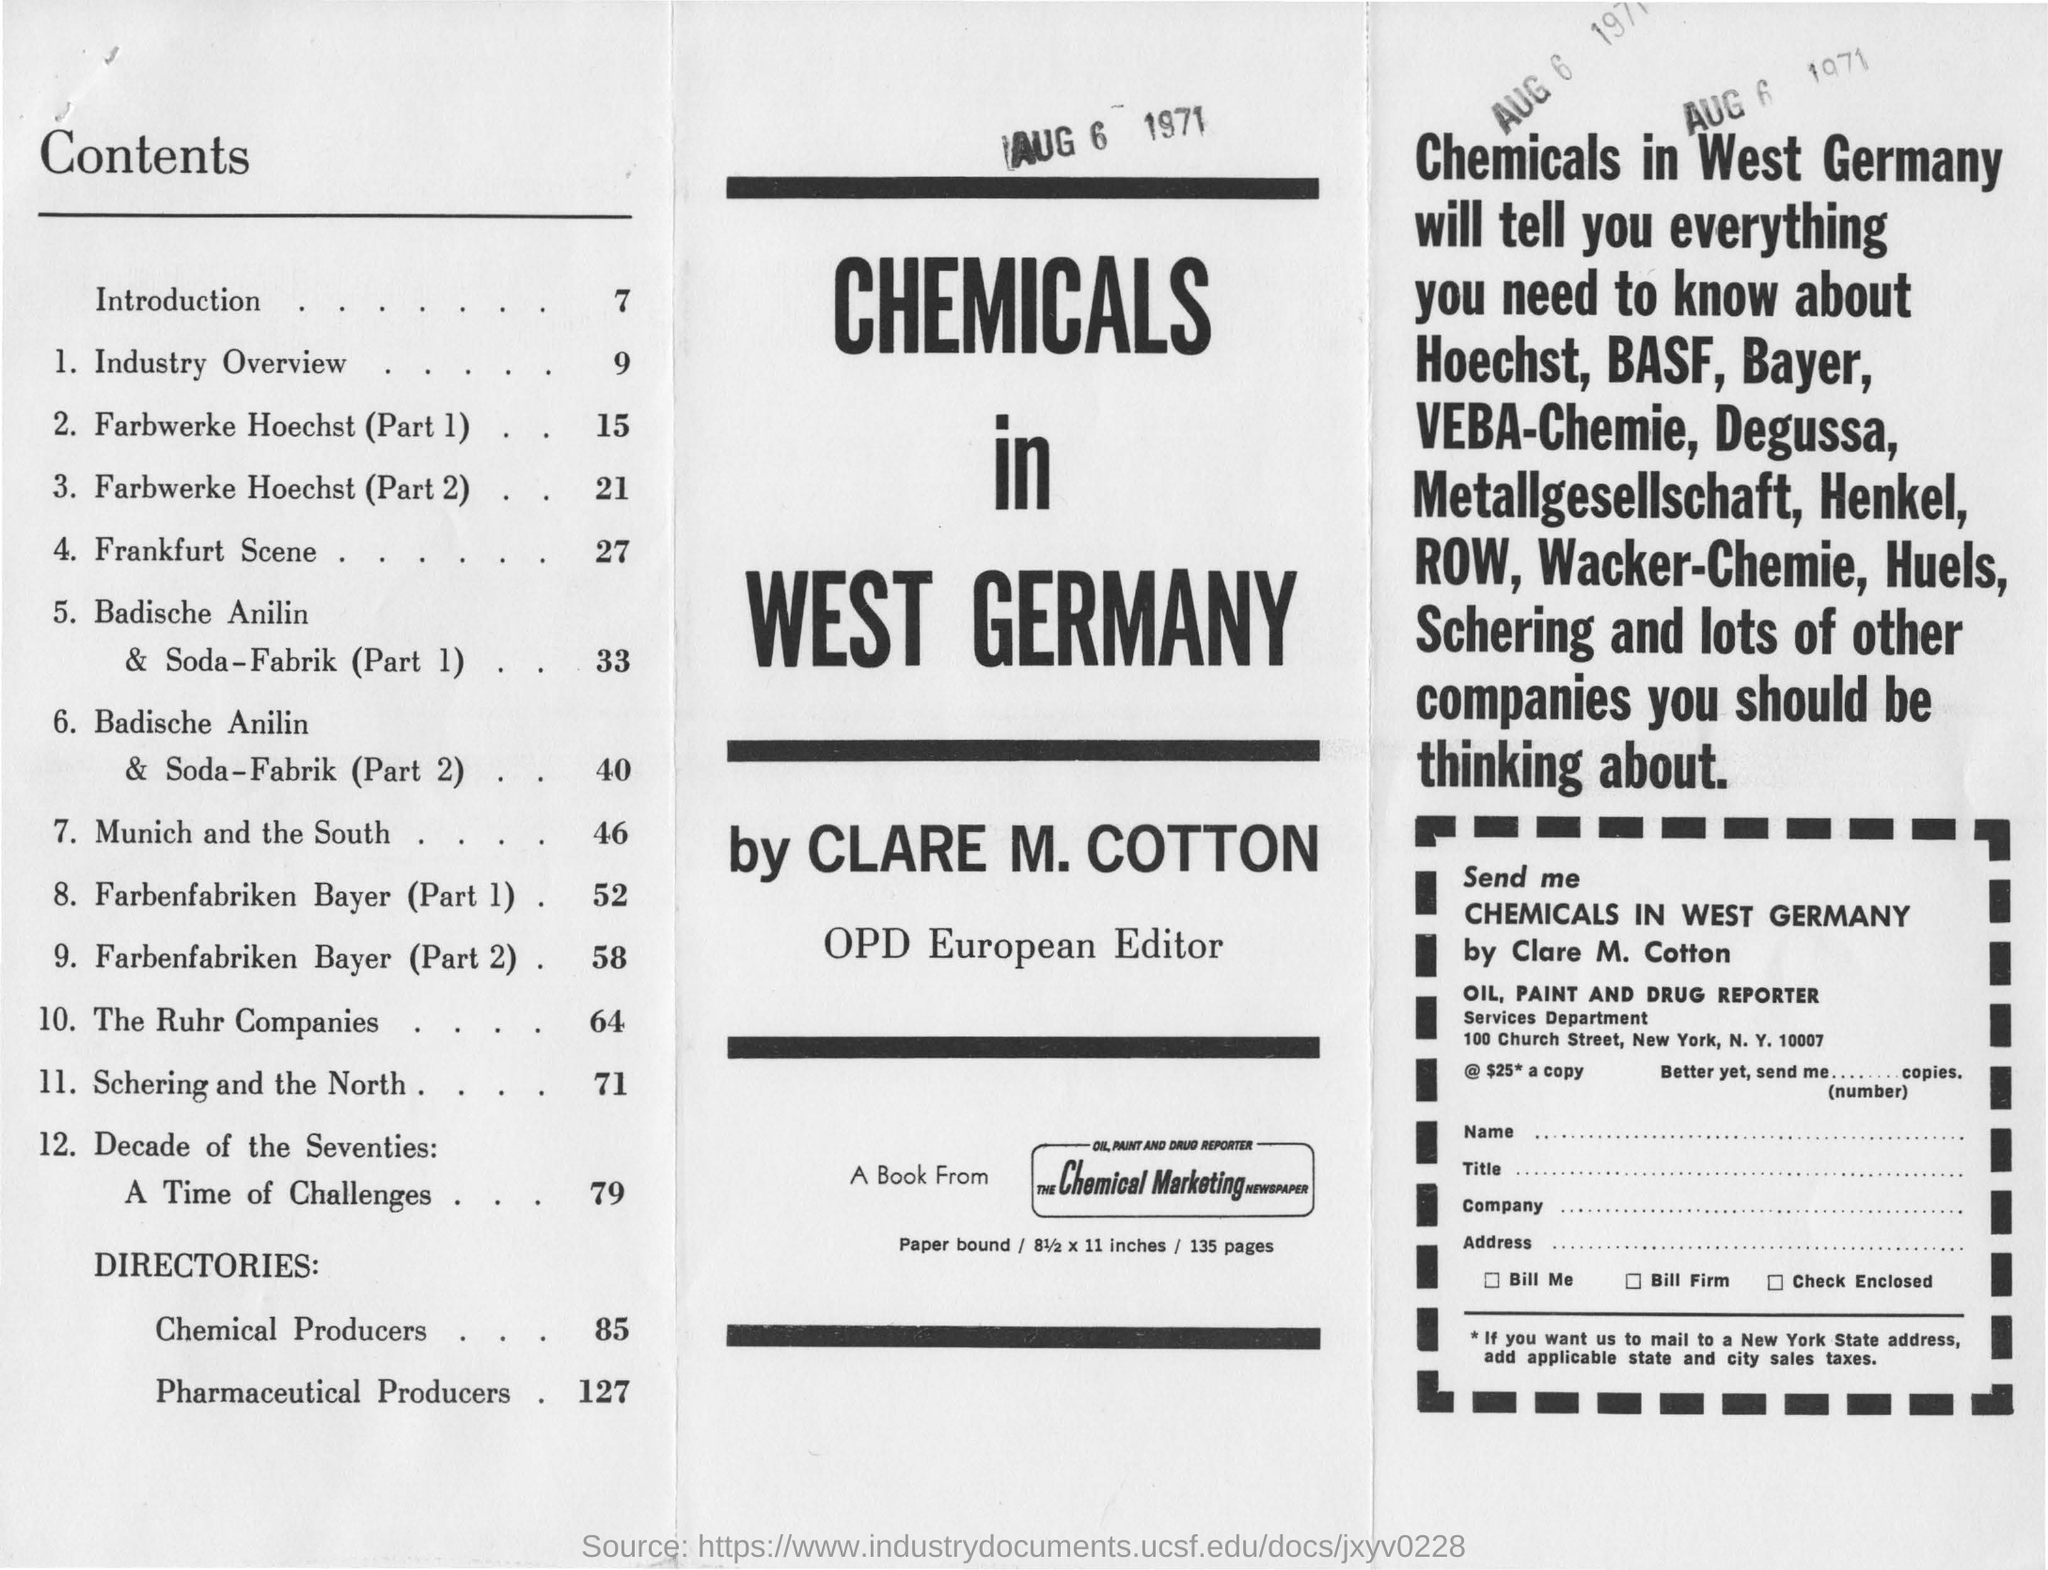Specify some key components in this picture. The Chemical Marketing Newspaper is the source of the book. The industry overview is located on page 9. Clare M. Cotton wrote about chemicals in West Germany. The introduction is located on page 7. 